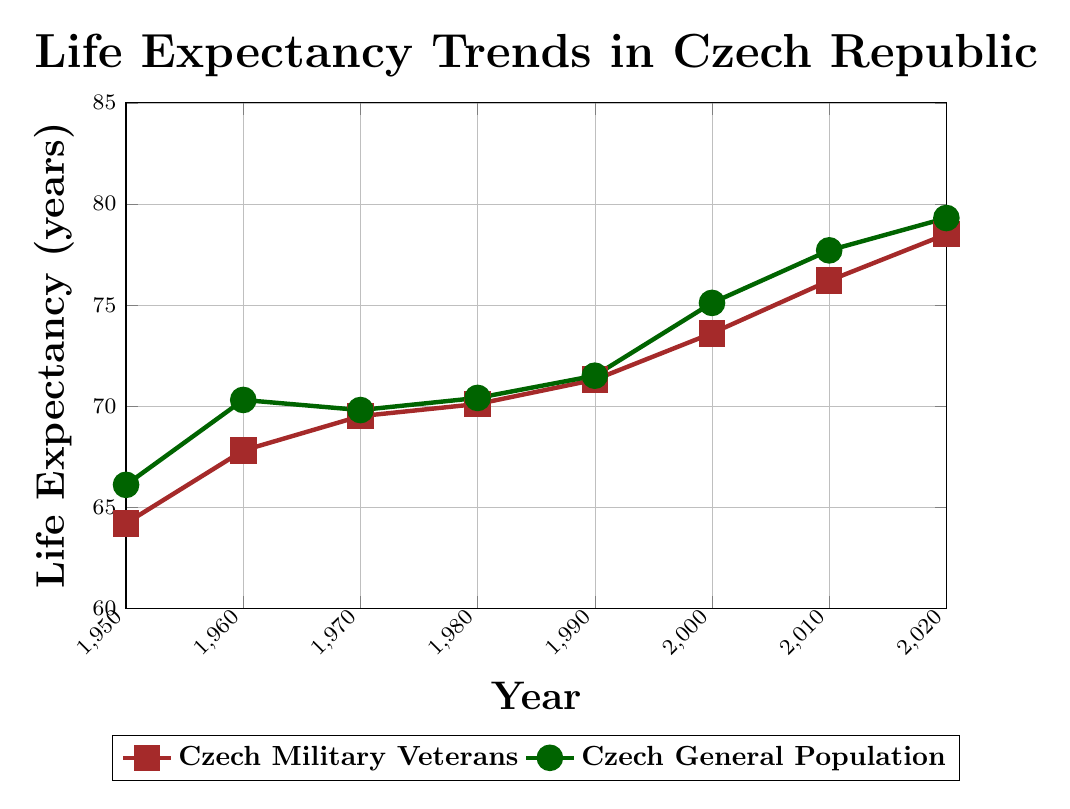What's the life expectancy of Czech military veterans in 1980? Identify the point on the line representing Czech military veterans in 1980, and note the corresponding value on the y-axis.
Answer: 70.1 What is the overall trend in life expectancy for both groups from 1950 to 2020? Observe how the lines for both groups move from left to right across the years. Both lines generally show an upward trend, indicating an increase in life expectancy.
Answer: Upward trend By how much did the life expectancy of the general population increase from 1950 to 2020? Subtract the life expectancy of the general population in 1950 from that in 2020: 79.3 - 66.1 = 13.2
Answer: 13.2 years Which group had higher life expectancy in 1960? Compare the values for both groups in 1960. The general population had a life expectancy of 70.3, while the veterans had 67.8.
Answer: General population What is the difference in life expectancy between Czech military veterans and the general population in 2000? Subtract the life expectancy of veterans from the general population: 75.1 - 73.6 = 1.5
Answer: 1.5 years During which decade did Czech military veterans' life expectancy first surpass 70 years? Locate the decade where the life expectancy of veterans moves above 70 on the y-axis. This occurs in the 1980s.
Answer: 1980s How does the life expectancy of Czech military veterans compare to the general population in 2020? Compare the values for both groups in 2020. The general population's life expectancy is 79.3, while veterans' is 78.5. The general population's life expectancy is higher.
Answer: General population higher What was the average life expectancy of Czech military veterans from 1950 to 2020? Calculate the average by summing the life expectancy values for veterans across all years and dividing by the number of data points: (64.2 + 67.8 + 69.5 + 70.1 + 71.3 + 73.6 + 76.2 + 78.5) / 8 = 71.525
Answer: 71.5 years When did the life expectancy of the general population experience the least growth compared to the previous decade? Observe the slope of the general population's line between each decade. The smallest increase is observed between 1970 and 1980.
Answer: 1970-1980 Explain the trend of life expectancy for Czech military veterans compared to the general population between 1990 and 2020. Identify the points for 1990, 2000, 2010, and 2020 for both groups and compare. The general population always has slightly higher values, but both trends are closely aligned and both increase over this period.
Answer: Both increase, general population slightly higher 